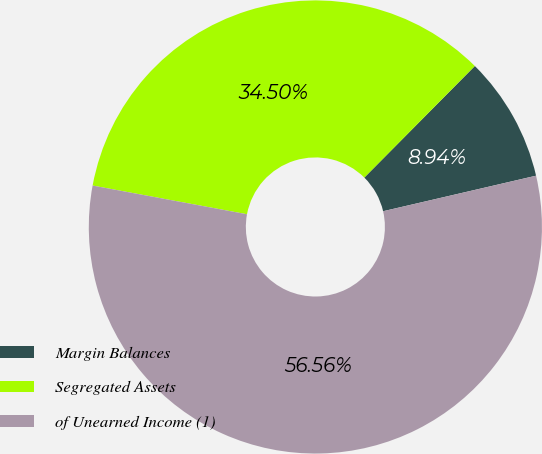Convert chart. <chart><loc_0><loc_0><loc_500><loc_500><pie_chart><fcel>Margin Balances<fcel>Segregated Assets<fcel>of Unearned Income (1)<nl><fcel>8.94%<fcel>34.5%<fcel>56.56%<nl></chart> 